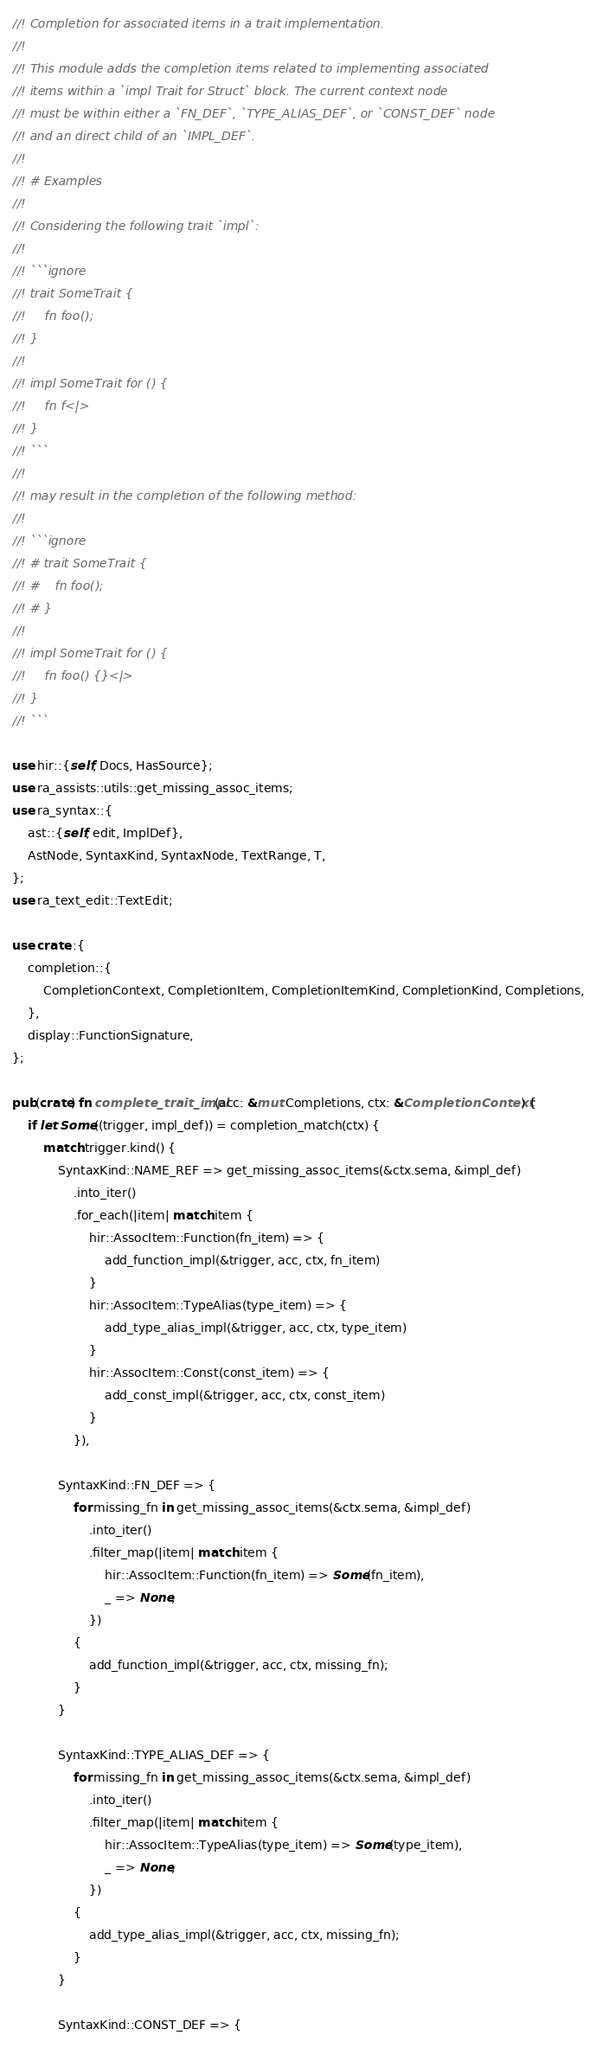<code> <loc_0><loc_0><loc_500><loc_500><_Rust_>//! Completion for associated items in a trait implementation.
//!
//! This module adds the completion items related to implementing associated
//! items within a `impl Trait for Struct` block. The current context node
//! must be within either a `FN_DEF`, `TYPE_ALIAS_DEF`, or `CONST_DEF` node
//! and an direct child of an `IMPL_DEF`.
//!
//! # Examples
//!
//! Considering the following trait `impl`:
//!
//! ```ignore
//! trait SomeTrait {
//!     fn foo();
//! }
//!
//! impl SomeTrait for () {
//!     fn f<|>
//! }
//! ```
//!
//! may result in the completion of the following method:
//!
//! ```ignore
//! # trait SomeTrait {
//! #    fn foo();
//! # }
//!
//! impl SomeTrait for () {
//!     fn foo() {}<|>
//! }
//! ```

use hir::{self, Docs, HasSource};
use ra_assists::utils::get_missing_assoc_items;
use ra_syntax::{
    ast::{self, edit, ImplDef},
    AstNode, SyntaxKind, SyntaxNode, TextRange, T,
};
use ra_text_edit::TextEdit;

use crate::{
    completion::{
        CompletionContext, CompletionItem, CompletionItemKind, CompletionKind, Completions,
    },
    display::FunctionSignature,
};

pub(crate) fn complete_trait_impl(acc: &mut Completions, ctx: &CompletionContext) {
    if let Some((trigger, impl_def)) = completion_match(ctx) {
        match trigger.kind() {
            SyntaxKind::NAME_REF => get_missing_assoc_items(&ctx.sema, &impl_def)
                .into_iter()
                .for_each(|item| match item {
                    hir::AssocItem::Function(fn_item) => {
                        add_function_impl(&trigger, acc, ctx, fn_item)
                    }
                    hir::AssocItem::TypeAlias(type_item) => {
                        add_type_alias_impl(&trigger, acc, ctx, type_item)
                    }
                    hir::AssocItem::Const(const_item) => {
                        add_const_impl(&trigger, acc, ctx, const_item)
                    }
                }),

            SyntaxKind::FN_DEF => {
                for missing_fn in get_missing_assoc_items(&ctx.sema, &impl_def)
                    .into_iter()
                    .filter_map(|item| match item {
                        hir::AssocItem::Function(fn_item) => Some(fn_item),
                        _ => None,
                    })
                {
                    add_function_impl(&trigger, acc, ctx, missing_fn);
                }
            }

            SyntaxKind::TYPE_ALIAS_DEF => {
                for missing_fn in get_missing_assoc_items(&ctx.sema, &impl_def)
                    .into_iter()
                    .filter_map(|item| match item {
                        hir::AssocItem::TypeAlias(type_item) => Some(type_item),
                        _ => None,
                    })
                {
                    add_type_alias_impl(&trigger, acc, ctx, missing_fn);
                }
            }

            SyntaxKind::CONST_DEF => {</code> 